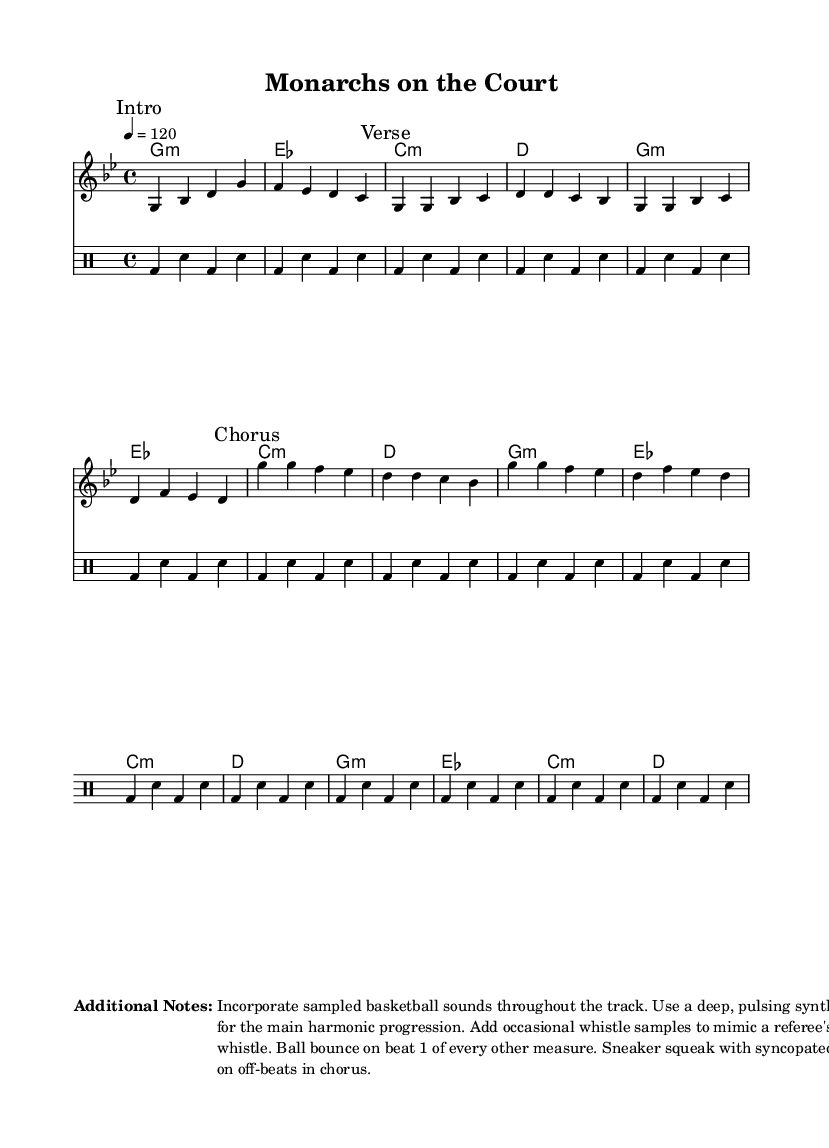What is the key signature of this music? The key signature is G minor, indicated by the one flat (B♭) present in the key signature at the beginning of the score.
Answer: G minor What is the time signature of the piece? The time signature is 4/4, shown at the beginning of the score where it indicates four beats per measure, with a quarter note receiving one beat.
Answer: 4/4 What is the tempo marking of the music? The tempo marking indicates a speed of 120 beats per minute, specified at the beginning of the score with "4 = 120".
Answer: 120 How many measures are in the "Verse" section? The "Verse" section consists of 4 measures, as indicated by the musical notation in that part of the score.
Answer: 4 measures What musical element represents basketball sounds in the track? The drum part, particularly with the repeated bounce drum (bd) and snare (sn) pattern, represents basketball sounds like bouncing balls and squeaking sneakers.
Answer: Drum pattern Which section has a different melodic line compared to the "Verse"? The "Chorus" section features a different melodic line, evidenced by a different arrangement of notes compared to the "Verse" section.
Answer: Chorus What type of samples should be incorporated throughout the track? The track should incorporate sampled basketball sounds, as described in the additional notes section at the bottom of the score.
Answer: Basketball sounds 